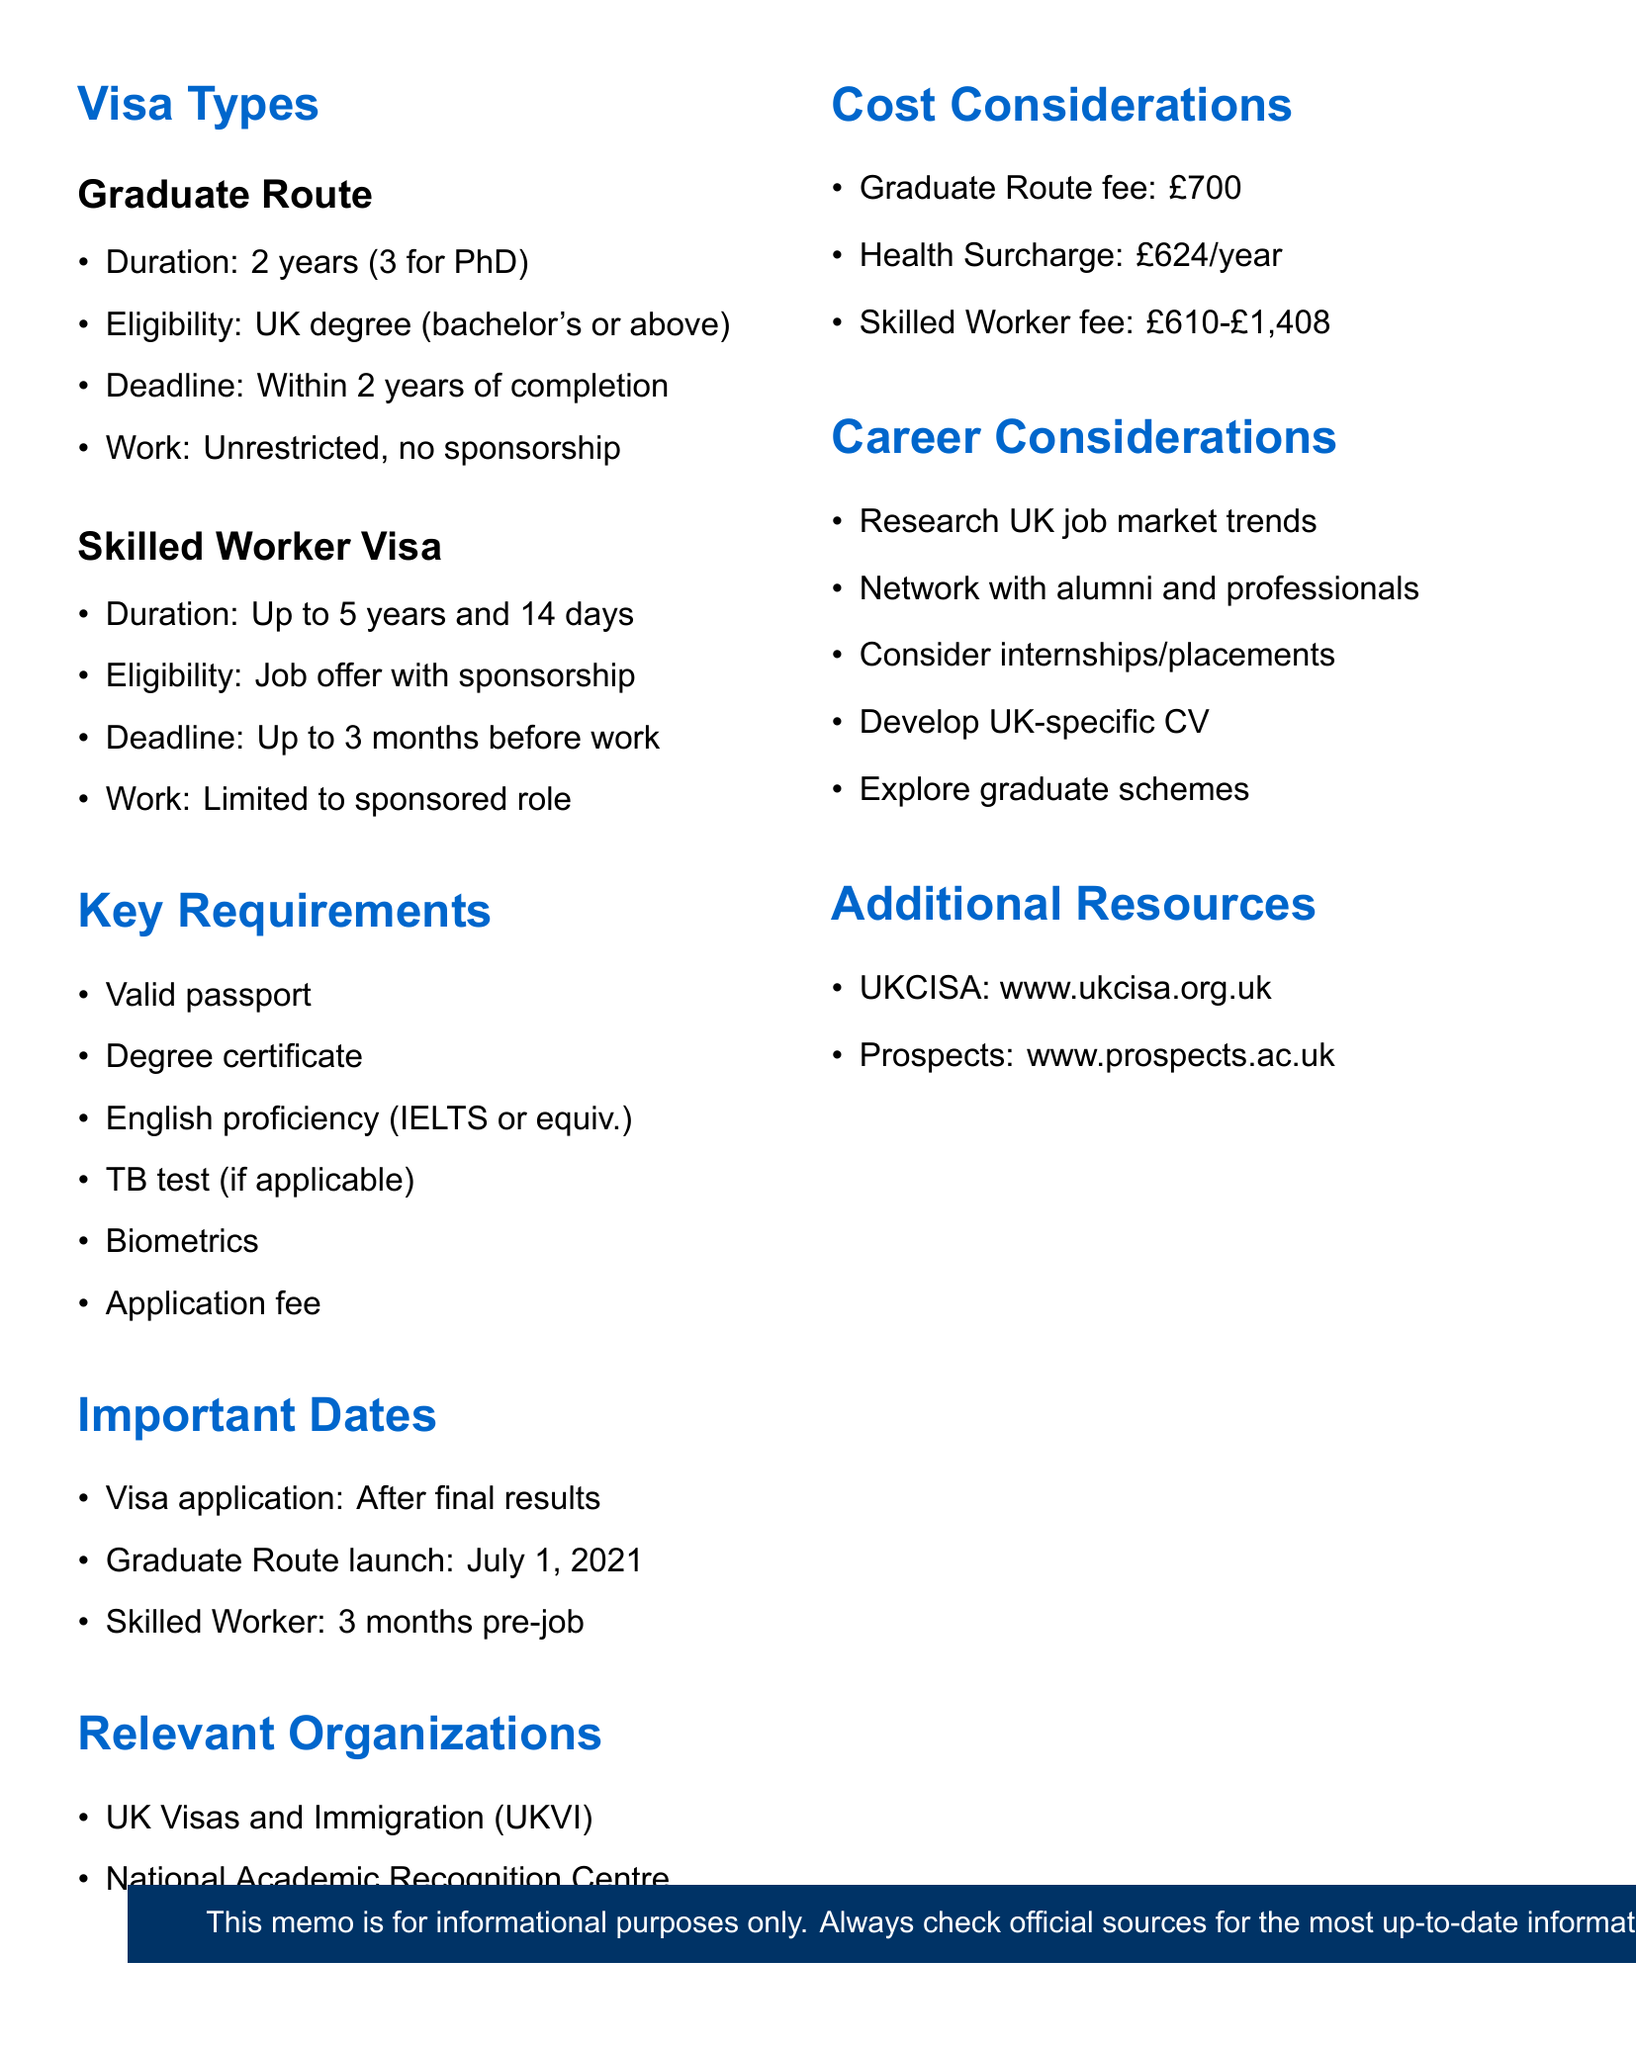what is the duration of the Graduate Route? The document states that the duration is 2 years, with an extension to 3 years for PhD graduates.
Answer: 2 years (3 years for PhD graduates) what is the application deadline for the Graduate Route? The document specifies that applications must be submitted within 2 years of course completion.
Answer: Within 2 years of course completion what is the cost of the Graduate Route application fee? According to the document, the application fee for the Graduate Route is mentioned in the cost considerations section.
Answer: £700 what is one of the key requirements for obtaining a Skilled Worker Visa? The document lists several key requirements, including having a job offer from a UK employer with valid sponsorship.
Answer: Job offer from a UK employer with a valid sponsorship license when was the Graduate Route launched? The document provides a specific date in the important dates section.
Answer: July 1, 2021 what organization is responsible for UK visas and immigration? The relevant organizations section mentions the authority overseeing UK visas and immigration.
Answer: UK Visas and Immigration (UKVI) what is a career consideration mentioned in the document? The document lists several career considerations for international students, including networking and researching job trends.
Answer: Network with alumni and professionals in target industries what is the duration of the Skilled Worker Visa? The document indicates that the Skilled Worker Visa duration is detailed in the visa types section.
Answer: Up to 5 years and 14 days what is the website for UKCISA? The additional resources section provides a website for UKCISA.
Answer: https://www.ukcisa.org.uk/ 